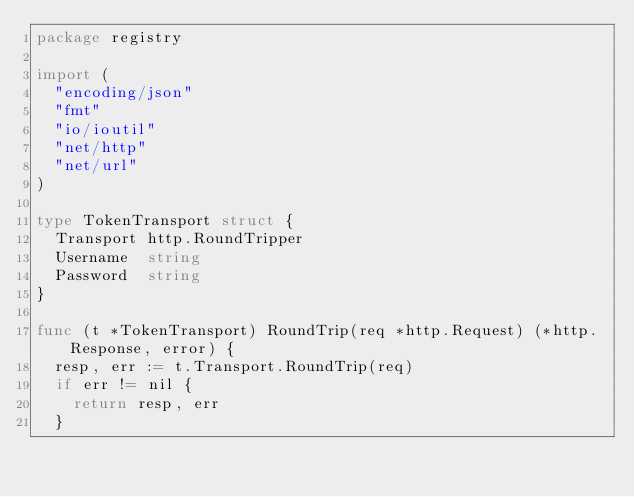<code> <loc_0><loc_0><loc_500><loc_500><_Go_>package registry

import (
	"encoding/json"
	"fmt"
	"io/ioutil"
	"net/http"
	"net/url"
)

type TokenTransport struct {
	Transport http.RoundTripper
	Username  string
	Password  string
}

func (t *TokenTransport) RoundTrip(req *http.Request) (*http.Response, error) {
	resp, err := t.Transport.RoundTrip(req)
	if err != nil {
		return resp, err
	}</code> 